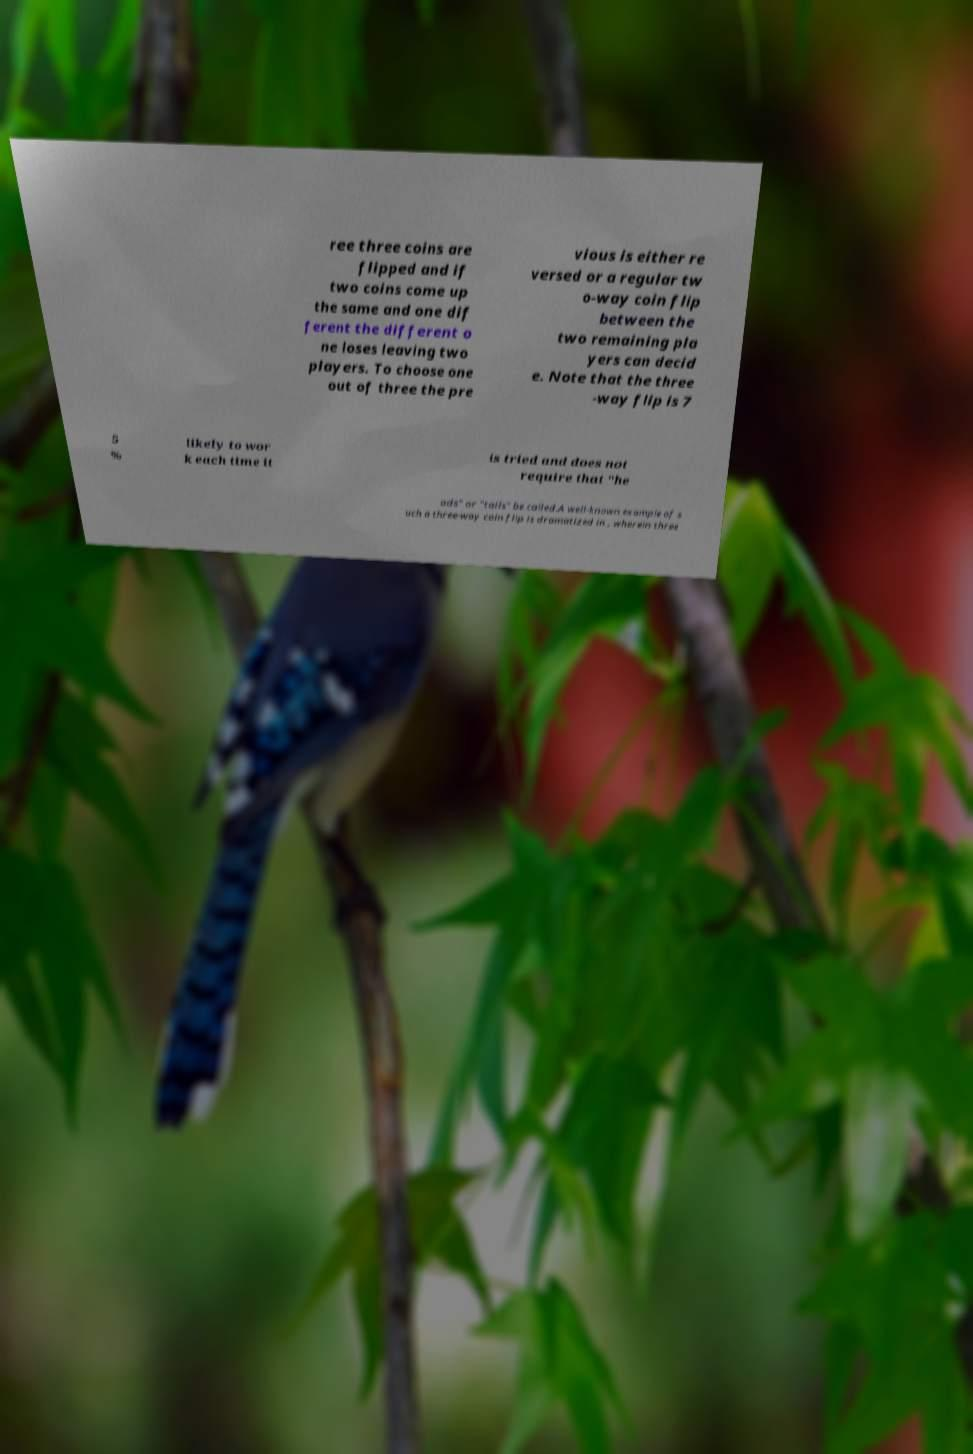Can you accurately transcribe the text from the provided image for me? ree three coins are flipped and if two coins come up the same and one dif ferent the different o ne loses leaving two players. To choose one out of three the pre vious is either re versed or a regular tw o-way coin flip between the two remaining pla yers can decid e. Note that the three -way flip is 7 5 % likely to wor k each time it is tried and does not require that "he ads" or "tails" be called.A well-known example of s uch a three-way coin flip is dramatized in , wherein three 